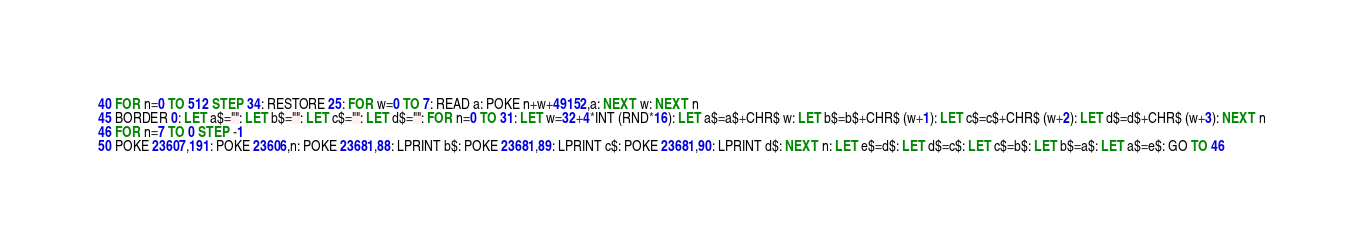<code> <loc_0><loc_0><loc_500><loc_500><_VisualBasic_>40 FOR n=0 TO 512 STEP 34: RESTORE 25: FOR w=0 TO 7: READ a: POKE n+w+49152,a: NEXT w: NEXT n
45 BORDER 0: LET a$="": LET b$="": LET c$="": LET d$="": FOR n=0 TO 31: LET w=32+4*INT (RND*16): LET a$=a$+CHR$ w: LET b$=b$+CHR$ (w+1): LET c$=c$+CHR$ (w+2): LET d$=d$+CHR$ (w+3): NEXT n
46 FOR n=7 TO 0 STEP -1
50 POKE 23607,191: POKE 23606,n: POKE 23681,88: LPRINT b$: POKE 23681,89: LPRINT c$: POKE 23681,90: LPRINT d$: NEXT n: LET e$=d$: LET d$=c$: LET c$=b$: LET b$=a$: LET a$=e$: GO TO 46

</code> 